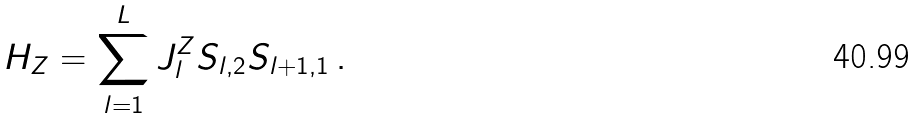Convert formula to latex. <formula><loc_0><loc_0><loc_500><loc_500>H _ { Z } = \sum _ { l = 1 } ^ { L } J _ { l } ^ { Z } { S } _ { l , 2 } { S } _ { l + 1 , 1 } \, .</formula> 